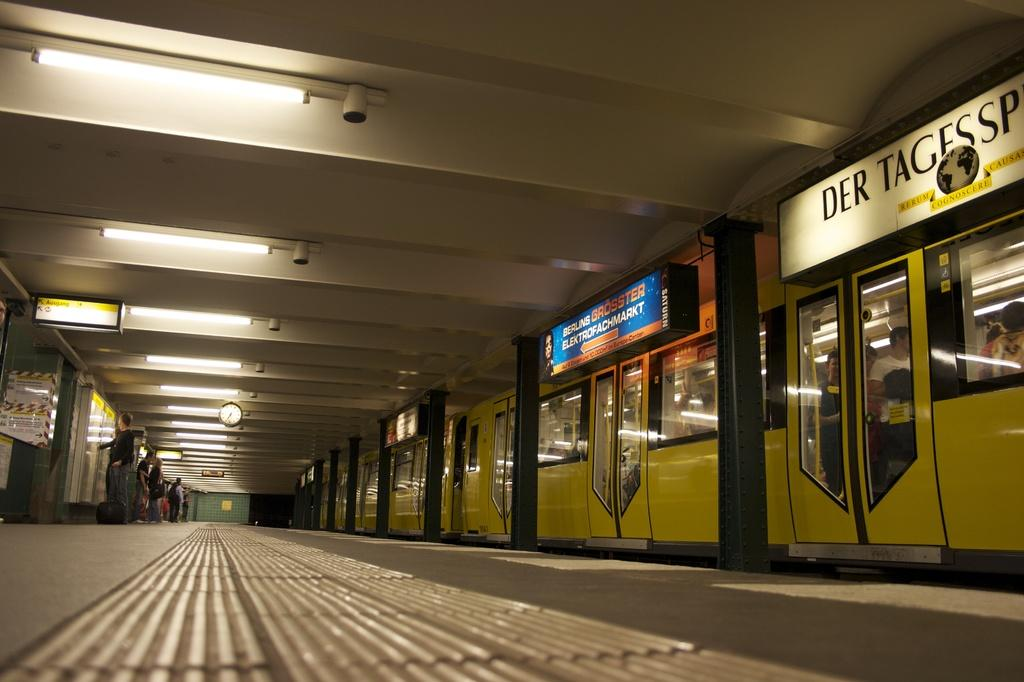What type of architectural feature can be seen in the image? There are doors in the image. What is covering the doors? The doors have boards on them. What can be used to provide illumination in the image? There are lights in the image. What device is used to measure time in the image? There is a clock in the image. What is the position of the people in the image? There are people on the floor in the image. What type of stamp can be seen on the edge of the door in the image? There is no stamp present on the edge of the door in the image. 